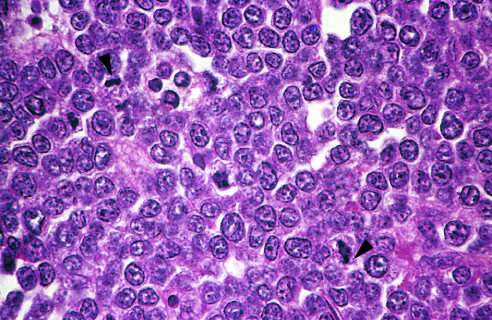how is the starry sky pattern produced?
Answer the question using a single word or phrase. By interspersed 